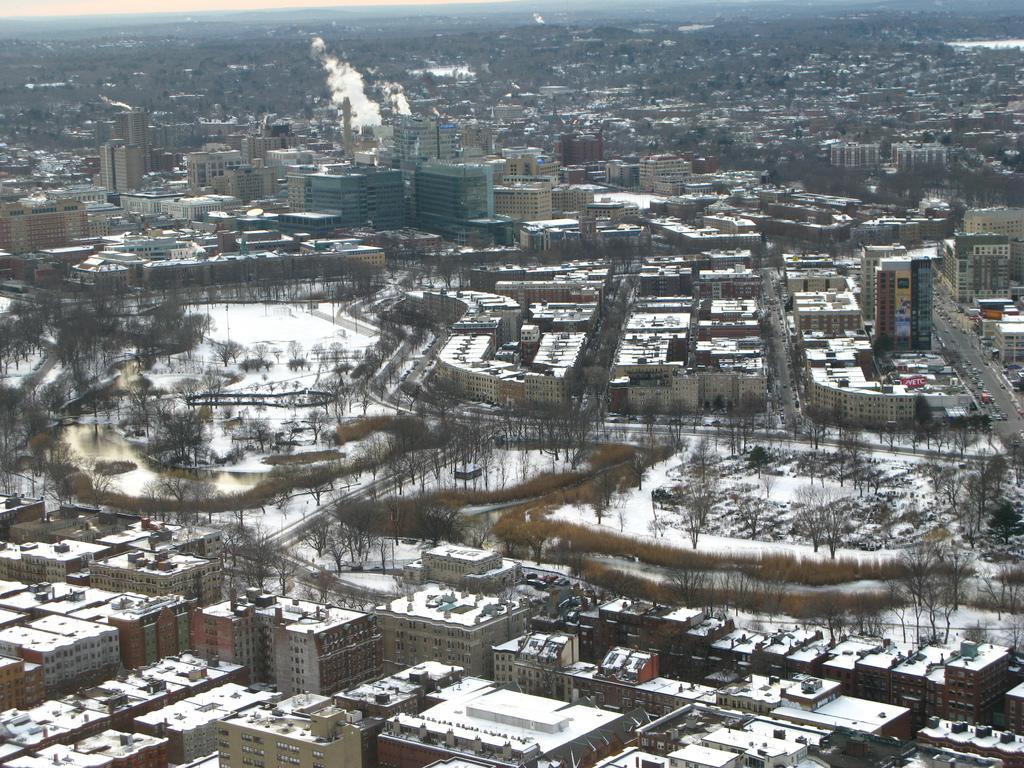Describe this image in one or two sentences. This is a picture of a city where there is snow, buildings, trees, roads, vehicles. 